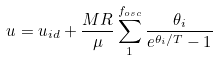Convert formula to latex. <formula><loc_0><loc_0><loc_500><loc_500>u = u _ { i d } + \frac { M R } { \mu } \sum _ { 1 } ^ { f _ { o s c } } { \frac { \theta _ { i } } { e ^ { \theta _ { i } / T } - 1 } }</formula> 